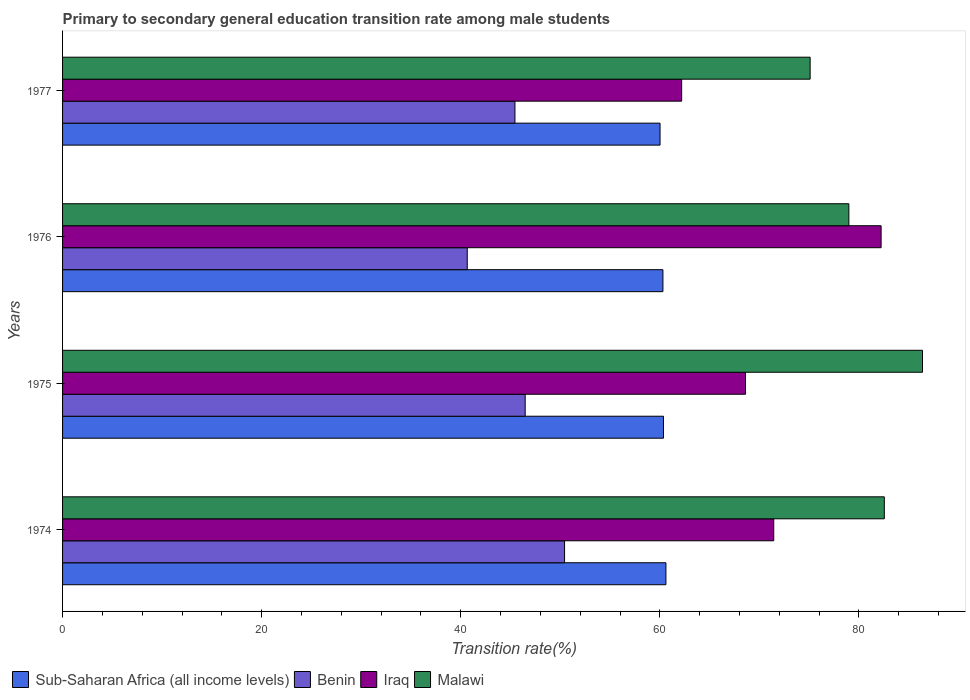How many different coloured bars are there?
Your response must be concise. 4. How many groups of bars are there?
Ensure brevity in your answer.  4. Are the number of bars per tick equal to the number of legend labels?
Give a very brief answer. Yes. How many bars are there on the 2nd tick from the bottom?
Make the answer very short. 4. What is the label of the 3rd group of bars from the top?
Your answer should be compact. 1975. What is the transition rate in Malawi in 1975?
Make the answer very short. 86.39. Across all years, what is the maximum transition rate in Sub-Saharan Africa (all income levels)?
Provide a succinct answer. 60.61. Across all years, what is the minimum transition rate in Iraq?
Your answer should be very brief. 62.19. In which year was the transition rate in Malawi maximum?
Offer a terse response. 1975. In which year was the transition rate in Sub-Saharan Africa (all income levels) minimum?
Give a very brief answer. 1977. What is the total transition rate in Sub-Saharan Africa (all income levels) in the graph?
Offer a terse response. 241.32. What is the difference between the transition rate in Benin in 1974 and that in 1976?
Provide a short and direct response. 9.78. What is the difference between the transition rate in Malawi in 1975 and the transition rate in Sub-Saharan Africa (all income levels) in 1974?
Ensure brevity in your answer.  25.78. What is the average transition rate in Malawi per year?
Your answer should be compact. 80.76. In the year 1977, what is the difference between the transition rate in Iraq and transition rate in Benin?
Keep it short and to the point. 16.75. In how many years, is the transition rate in Benin greater than 72 %?
Keep it short and to the point. 0. What is the ratio of the transition rate in Malawi in 1974 to that in 1976?
Provide a succinct answer. 1.05. Is the transition rate in Iraq in 1974 less than that in 1977?
Your response must be concise. No. Is the difference between the transition rate in Iraq in 1975 and 1977 greater than the difference between the transition rate in Benin in 1975 and 1977?
Your answer should be very brief. Yes. What is the difference between the highest and the second highest transition rate in Iraq?
Your response must be concise. 10.79. What is the difference between the highest and the lowest transition rate in Sub-Saharan Africa (all income levels)?
Offer a terse response. 0.59. Is it the case that in every year, the sum of the transition rate in Iraq and transition rate in Benin is greater than the sum of transition rate in Malawi and transition rate in Sub-Saharan Africa (all income levels)?
Give a very brief answer. Yes. What does the 3rd bar from the top in 1975 represents?
Your response must be concise. Benin. What does the 4th bar from the bottom in 1977 represents?
Provide a short and direct response. Malawi. Is it the case that in every year, the sum of the transition rate in Benin and transition rate in Malawi is greater than the transition rate in Iraq?
Make the answer very short. Yes. How many bars are there?
Keep it short and to the point. 16. Are all the bars in the graph horizontal?
Offer a very short reply. Yes. How many years are there in the graph?
Your answer should be compact. 4. Does the graph contain grids?
Provide a succinct answer. No. Where does the legend appear in the graph?
Provide a succinct answer. Bottom left. How many legend labels are there?
Keep it short and to the point. 4. What is the title of the graph?
Ensure brevity in your answer.  Primary to secondary general education transition rate among male students. Does "Moldova" appear as one of the legend labels in the graph?
Keep it short and to the point. No. What is the label or title of the X-axis?
Give a very brief answer. Transition rate(%). What is the Transition rate(%) in Sub-Saharan Africa (all income levels) in 1974?
Your response must be concise. 60.61. What is the Transition rate(%) in Benin in 1974?
Keep it short and to the point. 50.43. What is the Transition rate(%) of Iraq in 1974?
Keep it short and to the point. 71.45. What is the Transition rate(%) in Malawi in 1974?
Keep it short and to the point. 82.55. What is the Transition rate(%) in Sub-Saharan Africa (all income levels) in 1975?
Give a very brief answer. 60.37. What is the Transition rate(%) in Benin in 1975?
Make the answer very short. 46.47. What is the Transition rate(%) in Iraq in 1975?
Keep it short and to the point. 68.61. What is the Transition rate(%) in Malawi in 1975?
Provide a short and direct response. 86.39. What is the Transition rate(%) in Sub-Saharan Africa (all income levels) in 1976?
Offer a terse response. 60.31. What is the Transition rate(%) in Benin in 1976?
Your answer should be compact. 40.66. What is the Transition rate(%) of Iraq in 1976?
Offer a very short reply. 82.23. What is the Transition rate(%) in Malawi in 1976?
Offer a very short reply. 78.99. What is the Transition rate(%) in Sub-Saharan Africa (all income levels) in 1977?
Your answer should be compact. 60.02. What is the Transition rate(%) in Benin in 1977?
Your answer should be very brief. 45.45. What is the Transition rate(%) of Iraq in 1977?
Your answer should be very brief. 62.19. What is the Transition rate(%) of Malawi in 1977?
Offer a terse response. 75.1. Across all years, what is the maximum Transition rate(%) in Sub-Saharan Africa (all income levels)?
Make the answer very short. 60.61. Across all years, what is the maximum Transition rate(%) of Benin?
Ensure brevity in your answer.  50.43. Across all years, what is the maximum Transition rate(%) of Iraq?
Give a very brief answer. 82.23. Across all years, what is the maximum Transition rate(%) in Malawi?
Your response must be concise. 86.39. Across all years, what is the minimum Transition rate(%) in Sub-Saharan Africa (all income levels)?
Your answer should be compact. 60.02. Across all years, what is the minimum Transition rate(%) in Benin?
Ensure brevity in your answer.  40.66. Across all years, what is the minimum Transition rate(%) of Iraq?
Make the answer very short. 62.19. Across all years, what is the minimum Transition rate(%) in Malawi?
Offer a terse response. 75.1. What is the total Transition rate(%) of Sub-Saharan Africa (all income levels) in the graph?
Your answer should be compact. 241.32. What is the total Transition rate(%) of Benin in the graph?
Keep it short and to the point. 183.01. What is the total Transition rate(%) in Iraq in the graph?
Keep it short and to the point. 284.48. What is the total Transition rate(%) of Malawi in the graph?
Provide a short and direct response. 323.04. What is the difference between the Transition rate(%) in Sub-Saharan Africa (all income levels) in 1974 and that in 1975?
Provide a succinct answer. 0.25. What is the difference between the Transition rate(%) of Benin in 1974 and that in 1975?
Offer a terse response. 3.96. What is the difference between the Transition rate(%) in Iraq in 1974 and that in 1975?
Keep it short and to the point. 2.84. What is the difference between the Transition rate(%) of Malawi in 1974 and that in 1975?
Make the answer very short. -3.84. What is the difference between the Transition rate(%) in Sub-Saharan Africa (all income levels) in 1974 and that in 1976?
Your answer should be compact. 0.3. What is the difference between the Transition rate(%) in Benin in 1974 and that in 1976?
Your answer should be compact. 9.78. What is the difference between the Transition rate(%) of Iraq in 1974 and that in 1976?
Offer a very short reply. -10.79. What is the difference between the Transition rate(%) of Malawi in 1974 and that in 1976?
Provide a short and direct response. 3.56. What is the difference between the Transition rate(%) in Sub-Saharan Africa (all income levels) in 1974 and that in 1977?
Offer a very short reply. 0.59. What is the difference between the Transition rate(%) in Benin in 1974 and that in 1977?
Ensure brevity in your answer.  4.99. What is the difference between the Transition rate(%) in Iraq in 1974 and that in 1977?
Keep it short and to the point. 9.25. What is the difference between the Transition rate(%) in Malawi in 1974 and that in 1977?
Provide a short and direct response. 7.45. What is the difference between the Transition rate(%) in Sub-Saharan Africa (all income levels) in 1975 and that in 1976?
Make the answer very short. 0.05. What is the difference between the Transition rate(%) of Benin in 1975 and that in 1976?
Offer a very short reply. 5.82. What is the difference between the Transition rate(%) of Iraq in 1975 and that in 1976?
Provide a short and direct response. -13.62. What is the difference between the Transition rate(%) of Malawi in 1975 and that in 1976?
Ensure brevity in your answer.  7.4. What is the difference between the Transition rate(%) of Sub-Saharan Africa (all income levels) in 1975 and that in 1977?
Your response must be concise. 0.34. What is the difference between the Transition rate(%) in Benin in 1975 and that in 1977?
Provide a succinct answer. 1.03. What is the difference between the Transition rate(%) of Iraq in 1975 and that in 1977?
Give a very brief answer. 6.42. What is the difference between the Transition rate(%) of Malawi in 1975 and that in 1977?
Your answer should be compact. 11.29. What is the difference between the Transition rate(%) of Sub-Saharan Africa (all income levels) in 1976 and that in 1977?
Provide a succinct answer. 0.29. What is the difference between the Transition rate(%) in Benin in 1976 and that in 1977?
Keep it short and to the point. -4.79. What is the difference between the Transition rate(%) in Iraq in 1976 and that in 1977?
Offer a very short reply. 20.04. What is the difference between the Transition rate(%) in Malawi in 1976 and that in 1977?
Make the answer very short. 3.89. What is the difference between the Transition rate(%) of Sub-Saharan Africa (all income levels) in 1974 and the Transition rate(%) of Benin in 1975?
Your answer should be compact. 14.14. What is the difference between the Transition rate(%) in Sub-Saharan Africa (all income levels) in 1974 and the Transition rate(%) in Iraq in 1975?
Make the answer very short. -8. What is the difference between the Transition rate(%) in Sub-Saharan Africa (all income levels) in 1974 and the Transition rate(%) in Malawi in 1975?
Your answer should be very brief. -25.78. What is the difference between the Transition rate(%) in Benin in 1974 and the Transition rate(%) in Iraq in 1975?
Make the answer very short. -18.18. What is the difference between the Transition rate(%) in Benin in 1974 and the Transition rate(%) in Malawi in 1975?
Make the answer very short. -35.96. What is the difference between the Transition rate(%) in Iraq in 1974 and the Transition rate(%) in Malawi in 1975?
Offer a terse response. -14.94. What is the difference between the Transition rate(%) in Sub-Saharan Africa (all income levels) in 1974 and the Transition rate(%) in Benin in 1976?
Offer a terse response. 19.96. What is the difference between the Transition rate(%) of Sub-Saharan Africa (all income levels) in 1974 and the Transition rate(%) of Iraq in 1976?
Keep it short and to the point. -21.62. What is the difference between the Transition rate(%) in Sub-Saharan Africa (all income levels) in 1974 and the Transition rate(%) in Malawi in 1976?
Your answer should be very brief. -18.38. What is the difference between the Transition rate(%) in Benin in 1974 and the Transition rate(%) in Iraq in 1976?
Your answer should be compact. -31.8. What is the difference between the Transition rate(%) in Benin in 1974 and the Transition rate(%) in Malawi in 1976?
Provide a succinct answer. -28.56. What is the difference between the Transition rate(%) of Iraq in 1974 and the Transition rate(%) of Malawi in 1976?
Make the answer very short. -7.55. What is the difference between the Transition rate(%) in Sub-Saharan Africa (all income levels) in 1974 and the Transition rate(%) in Benin in 1977?
Ensure brevity in your answer.  15.17. What is the difference between the Transition rate(%) of Sub-Saharan Africa (all income levels) in 1974 and the Transition rate(%) of Iraq in 1977?
Offer a very short reply. -1.58. What is the difference between the Transition rate(%) in Sub-Saharan Africa (all income levels) in 1974 and the Transition rate(%) in Malawi in 1977?
Provide a short and direct response. -14.49. What is the difference between the Transition rate(%) of Benin in 1974 and the Transition rate(%) of Iraq in 1977?
Ensure brevity in your answer.  -11.76. What is the difference between the Transition rate(%) in Benin in 1974 and the Transition rate(%) in Malawi in 1977?
Offer a terse response. -24.67. What is the difference between the Transition rate(%) in Iraq in 1974 and the Transition rate(%) in Malawi in 1977?
Give a very brief answer. -3.66. What is the difference between the Transition rate(%) in Sub-Saharan Africa (all income levels) in 1975 and the Transition rate(%) in Benin in 1976?
Your answer should be compact. 19.71. What is the difference between the Transition rate(%) of Sub-Saharan Africa (all income levels) in 1975 and the Transition rate(%) of Iraq in 1976?
Provide a succinct answer. -21.87. What is the difference between the Transition rate(%) in Sub-Saharan Africa (all income levels) in 1975 and the Transition rate(%) in Malawi in 1976?
Keep it short and to the point. -18.62. What is the difference between the Transition rate(%) of Benin in 1975 and the Transition rate(%) of Iraq in 1976?
Ensure brevity in your answer.  -35.76. What is the difference between the Transition rate(%) in Benin in 1975 and the Transition rate(%) in Malawi in 1976?
Ensure brevity in your answer.  -32.52. What is the difference between the Transition rate(%) in Iraq in 1975 and the Transition rate(%) in Malawi in 1976?
Provide a succinct answer. -10.38. What is the difference between the Transition rate(%) in Sub-Saharan Africa (all income levels) in 1975 and the Transition rate(%) in Benin in 1977?
Offer a terse response. 14.92. What is the difference between the Transition rate(%) in Sub-Saharan Africa (all income levels) in 1975 and the Transition rate(%) in Iraq in 1977?
Give a very brief answer. -1.83. What is the difference between the Transition rate(%) in Sub-Saharan Africa (all income levels) in 1975 and the Transition rate(%) in Malawi in 1977?
Make the answer very short. -14.73. What is the difference between the Transition rate(%) in Benin in 1975 and the Transition rate(%) in Iraq in 1977?
Offer a very short reply. -15.72. What is the difference between the Transition rate(%) in Benin in 1975 and the Transition rate(%) in Malawi in 1977?
Your answer should be compact. -28.63. What is the difference between the Transition rate(%) of Iraq in 1975 and the Transition rate(%) of Malawi in 1977?
Make the answer very short. -6.49. What is the difference between the Transition rate(%) in Sub-Saharan Africa (all income levels) in 1976 and the Transition rate(%) in Benin in 1977?
Your answer should be compact. 14.87. What is the difference between the Transition rate(%) in Sub-Saharan Africa (all income levels) in 1976 and the Transition rate(%) in Iraq in 1977?
Your response must be concise. -1.88. What is the difference between the Transition rate(%) in Sub-Saharan Africa (all income levels) in 1976 and the Transition rate(%) in Malawi in 1977?
Keep it short and to the point. -14.79. What is the difference between the Transition rate(%) in Benin in 1976 and the Transition rate(%) in Iraq in 1977?
Provide a succinct answer. -21.54. What is the difference between the Transition rate(%) in Benin in 1976 and the Transition rate(%) in Malawi in 1977?
Give a very brief answer. -34.45. What is the difference between the Transition rate(%) in Iraq in 1976 and the Transition rate(%) in Malawi in 1977?
Provide a succinct answer. 7.13. What is the average Transition rate(%) of Sub-Saharan Africa (all income levels) per year?
Offer a terse response. 60.33. What is the average Transition rate(%) in Benin per year?
Your response must be concise. 45.75. What is the average Transition rate(%) of Iraq per year?
Offer a terse response. 71.12. What is the average Transition rate(%) of Malawi per year?
Keep it short and to the point. 80.76. In the year 1974, what is the difference between the Transition rate(%) of Sub-Saharan Africa (all income levels) and Transition rate(%) of Benin?
Provide a short and direct response. 10.18. In the year 1974, what is the difference between the Transition rate(%) of Sub-Saharan Africa (all income levels) and Transition rate(%) of Iraq?
Keep it short and to the point. -10.83. In the year 1974, what is the difference between the Transition rate(%) in Sub-Saharan Africa (all income levels) and Transition rate(%) in Malawi?
Ensure brevity in your answer.  -21.94. In the year 1974, what is the difference between the Transition rate(%) of Benin and Transition rate(%) of Iraq?
Offer a terse response. -21.01. In the year 1974, what is the difference between the Transition rate(%) of Benin and Transition rate(%) of Malawi?
Your answer should be compact. -32.12. In the year 1974, what is the difference between the Transition rate(%) in Iraq and Transition rate(%) in Malawi?
Offer a terse response. -11.11. In the year 1975, what is the difference between the Transition rate(%) in Sub-Saharan Africa (all income levels) and Transition rate(%) in Benin?
Keep it short and to the point. 13.89. In the year 1975, what is the difference between the Transition rate(%) in Sub-Saharan Africa (all income levels) and Transition rate(%) in Iraq?
Make the answer very short. -8.24. In the year 1975, what is the difference between the Transition rate(%) in Sub-Saharan Africa (all income levels) and Transition rate(%) in Malawi?
Offer a very short reply. -26.02. In the year 1975, what is the difference between the Transition rate(%) of Benin and Transition rate(%) of Iraq?
Give a very brief answer. -22.14. In the year 1975, what is the difference between the Transition rate(%) in Benin and Transition rate(%) in Malawi?
Keep it short and to the point. -39.91. In the year 1975, what is the difference between the Transition rate(%) in Iraq and Transition rate(%) in Malawi?
Ensure brevity in your answer.  -17.78. In the year 1976, what is the difference between the Transition rate(%) of Sub-Saharan Africa (all income levels) and Transition rate(%) of Benin?
Offer a very short reply. 19.66. In the year 1976, what is the difference between the Transition rate(%) of Sub-Saharan Africa (all income levels) and Transition rate(%) of Iraq?
Offer a terse response. -21.92. In the year 1976, what is the difference between the Transition rate(%) in Sub-Saharan Africa (all income levels) and Transition rate(%) in Malawi?
Offer a very short reply. -18.68. In the year 1976, what is the difference between the Transition rate(%) of Benin and Transition rate(%) of Iraq?
Give a very brief answer. -41.58. In the year 1976, what is the difference between the Transition rate(%) in Benin and Transition rate(%) in Malawi?
Your answer should be compact. -38.34. In the year 1976, what is the difference between the Transition rate(%) in Iraq and Transition rate(%) in Malawi?
Provide a succinct answer. 3.24. In the year 1977, what is the difference between the Transition rate(%) in Sub-Saharan Africa (all income levels) and Transition rate(%) in Benin?
Your answer should be very brief. 14.58. In the year 1977, what is the difference between the Transition rate(%) in Sub-Saharan Africa (all income levels) and Transition rate(%) in Iraq?
Keep it short and to the point. -2.17. In the year 1977, what is the difference between the Transition rate(%) of Sub-Saharan Africa (all income levels) and Transition rate(%) of Malawi?
Offer a very short reply. -15.08. In the year 1977, what is the difference between the Transition rate(%) in Benin and Transition rate(%) in Iraq?
Offer a very short reply. -16.75. In the year 1977, what is the difference between the Transition rate(%) in Benin and Transition rate(%) in Malawi?
Keep it short and to the point. -29.66. In the year 1977, what is the difference between the Transition rate(%) in Iraq and Transition rate(%) in Malawi?
Provide a succinct answer. -12.91. What is the ratio of the Transition rate(%) of Benin in 1974 to that in 1975?
Make the answer very short. 1.09. What is the ratio of the Transition rate(%) in Iraq in 1974 to that in 1975?
Your answer should be compact. 1.04. What is the ratio of the Transition rate(%) of Malawi in 1974 to that in 1975?
Provide a succinct answer. 0.96. What is the ratio of the Transition rate(%) in Sub-Saharan Africa (all income levels) in 1974 to that in 1976?
Provide a succinct answer. 1. What is the ratio of the Transition rate(%) of Benin in 1974 to that in 1976?
Make the answer very short. 1.24. What is the ratio of the Transition rate(%) in Iraq in 1974 to that in 1976?
Ensure brevity in your answer.  0.87. What is the ratio of the Transition rate(%) in Malawi in 1974 to that in 1976?
Offer a terse response. 1.05. What is the ratio of the Transition rate(%) of Sub-Saharan Africa (all income levels) in 1974 to that in 1977?
Give a very brief answer. 1.01. What is the ratio of the Transition rate(%) of Benin in 1974 to that in 1977?
Keep it short and to the point. 1.11. What is the ratio of the Transition rate(%) in Iraq in 1974 to that in 1977?
Offer a very short reply. 1.15. What is the ratio of the Transition rate(%) of Malawi in 1974 to that in 1977?
Your answer should be very brief. 1.1. What is the ratio of the Transition rate(%) of Benin in 1975 to that in 1976?
Your response must be concise. 1.14. What is the ratio of the Transition rate(%) of Iraq in 1975 to that in 1976?
Offer a very short reply. 0.83. What is the ratio of the Transition rate(%) in Malawi in 1975 to that in 1976?
Your answer should be very brief. 1.09. What is the ratio of the Transition rate(%) of Benin in 1975 to that in 1977?
Your answer should be very brief. 1.02. What is the ratio of the Transition rate(%) in Iraq in 1975 to that in 1977?
Make the answer very short. 1.1. What is the ratio of the Transition rate(%) of Malawi in 1975 to that in 1977?
Give a very brief answer. 1.15. What is the ratio of the Transition rate(%) of Sub-Saharan Africa (all income levels) in 1976 to that in 1977?
Give a very brief answer. 1. What is the ratio of the Transition rate(%) of Benin in 1976 to that in 1977?
Ensure brevity in your answer.  0.89. What is the ratio of the Transition rate(%) of Iraq in 1976 to that in 1977?
Make the answer very short. 1.32. What is the ratio of the Transition rate(%) in Malawi in 1976 to that in 1977?
Offer a terse response. 1.05. What is the difference between the highest and the second highest Transition rate(%) of Sub-Saharan Africa (all income levels)?
Offer a very short reply. 0.25. What is the difference between the highest and the second highest Transition rate(%) in Benin?
Provide a short and direct response. 3.96. What is the difference between the highest and the second highest Transition rate(%) of Iraq?
Ensure brevity in your answer.  10.79. What is the difference between the highest and the second highest Transition rate(%) of Malawi?
Ensure brevity in your answer.  3.84. What is the difference between the highest and the lowest Transition rate(%) in Sub-Saharan Africa (all income levels)?
Ensure brevity in your answer.  0.59. What is the difference between the highest and the lowest Transition rate(%) in Benin?
Your answer should be compact. 9.78. What is the difference between the highest and the lowest Transition rate(%) in Iraq?
Your response must be concise. 20.04. What is the difference between the highest and the lowest Transition rate(%) in Malawi?
Provide a short and direct response. 11.29. 